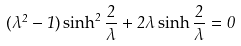<formula> <loc_0><loc_0><loc_500><loc_500>( \lambda ^ { 2 } - 1 ) \sinh ^ { 2 } \frac { 2 } { \lambda } + 2 \lambda \sinh \frac { 2 } { \lambda } = 0</formula> 